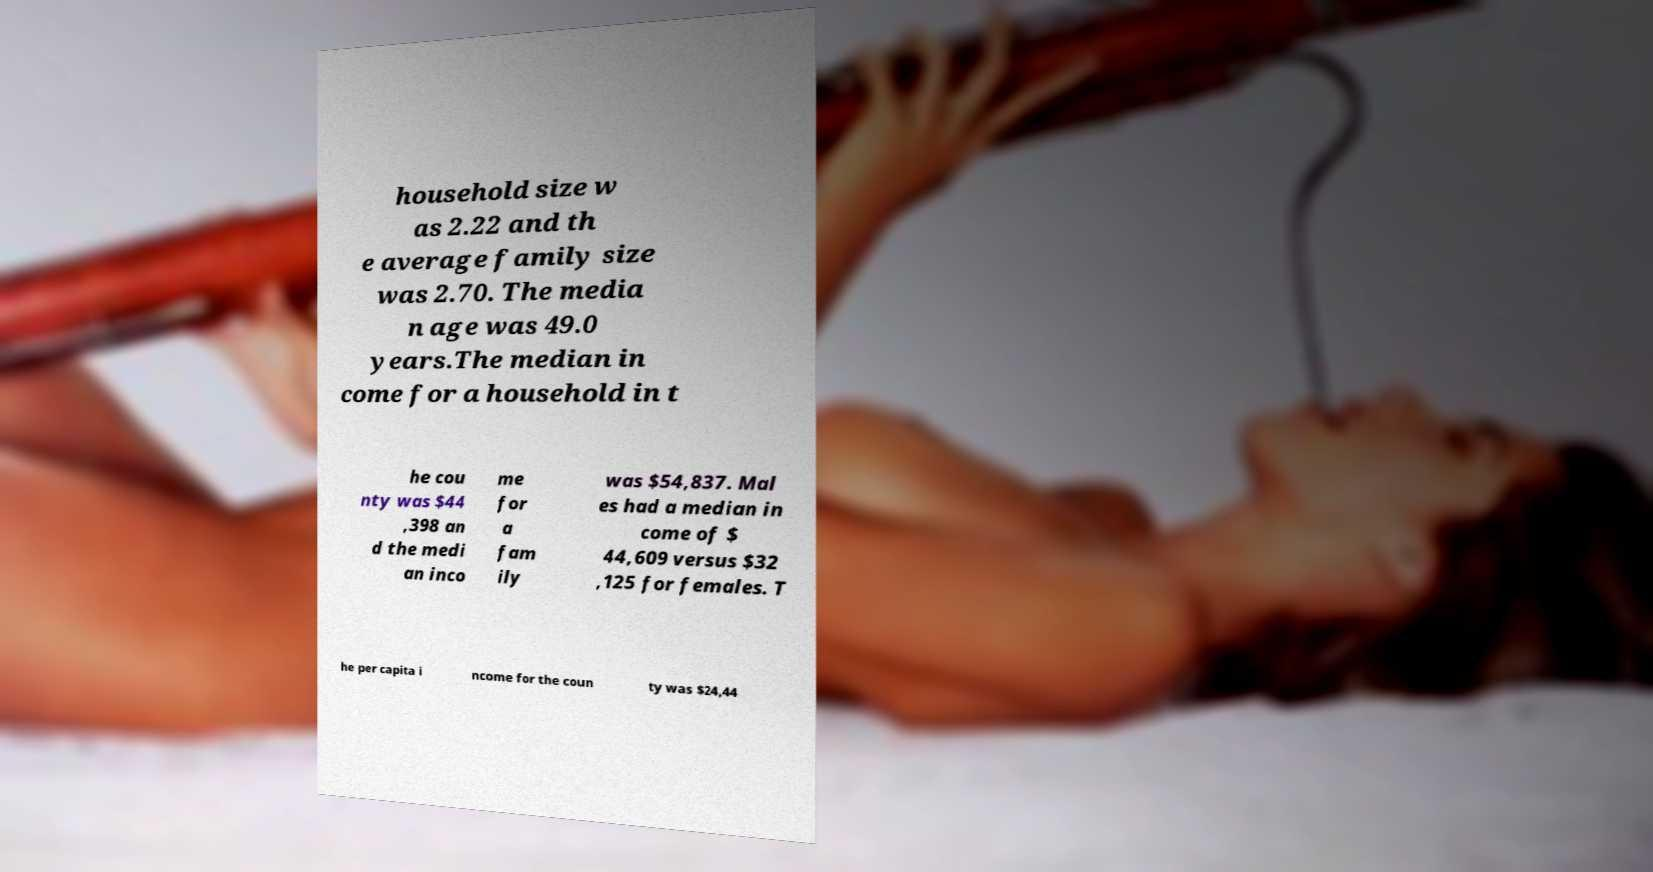Could you extract and type out the text from this image? household size w as 2.22 and th e average family size was 2.70. The media n age was 49.0 years.The median in come for a household in t he cou nty was $44 ,398 an d the medi an inco me for a fam ily was $54,837. Mal es had a median in come of $ 44,609 versus $32 ,125 for females. T he per capita i ncome for the coun ty was $24,44 